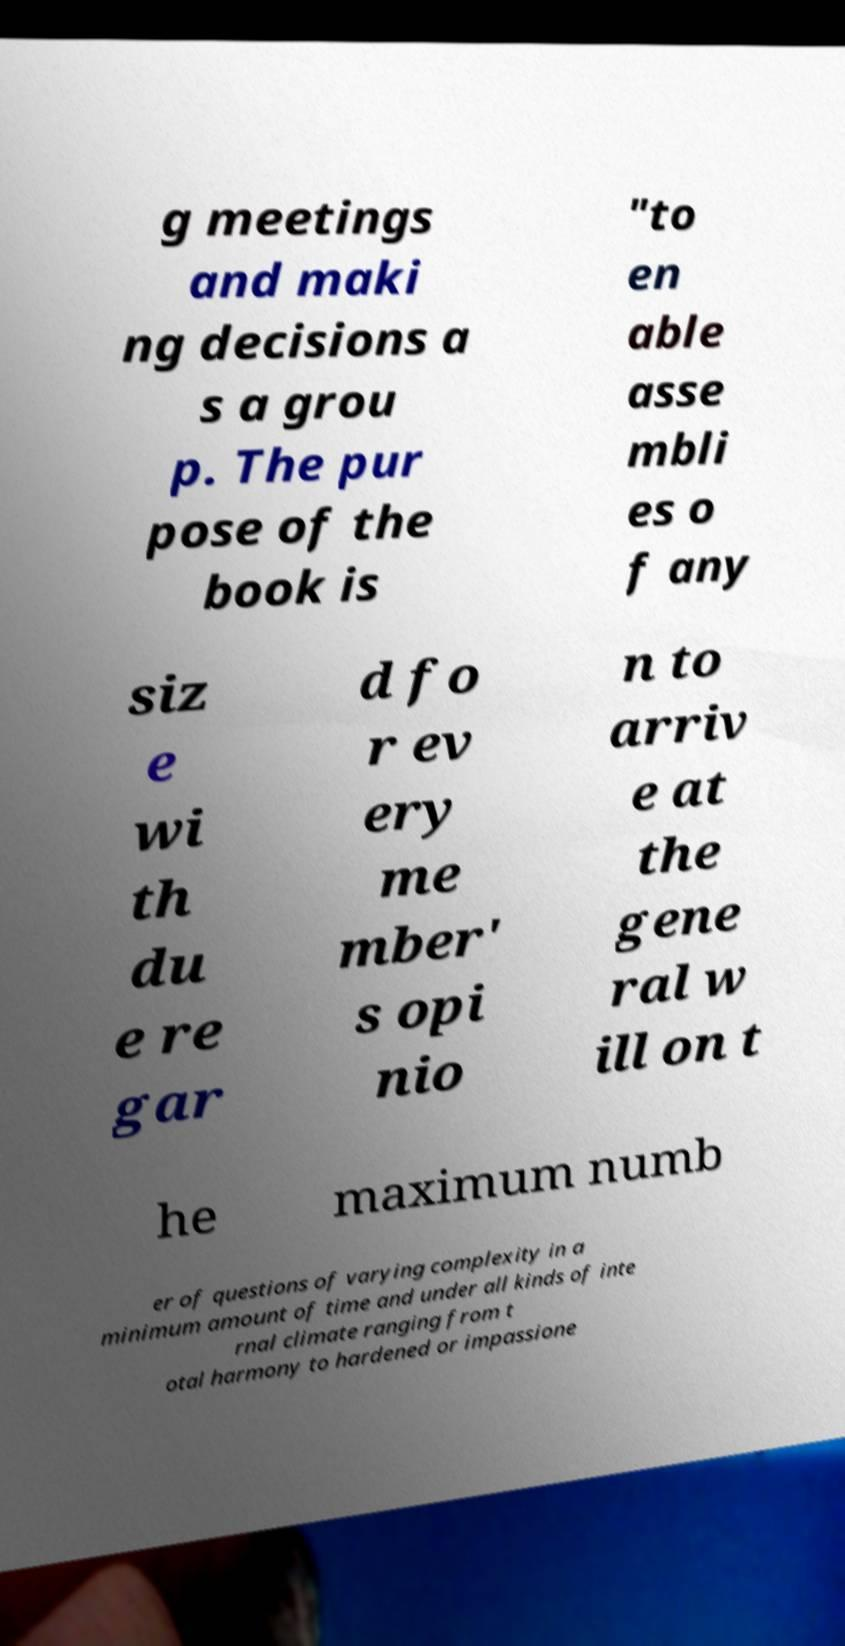What messages or text are displayed in this image? I need them in a readable, typed format. g meetings and maki ng decisions a s a grou p. The pur pose of the book is "to en able asse mbli es o f any siz e wi th du e re gar d fo r ev ery me mber' s opi nio n to arriv e at the gene ral w ill on t he maximum numb er of questions of varying complexity in a minimum amount of time and under all kinds of inte rnal climate ranging from t otal harmony to hardened or impassione 